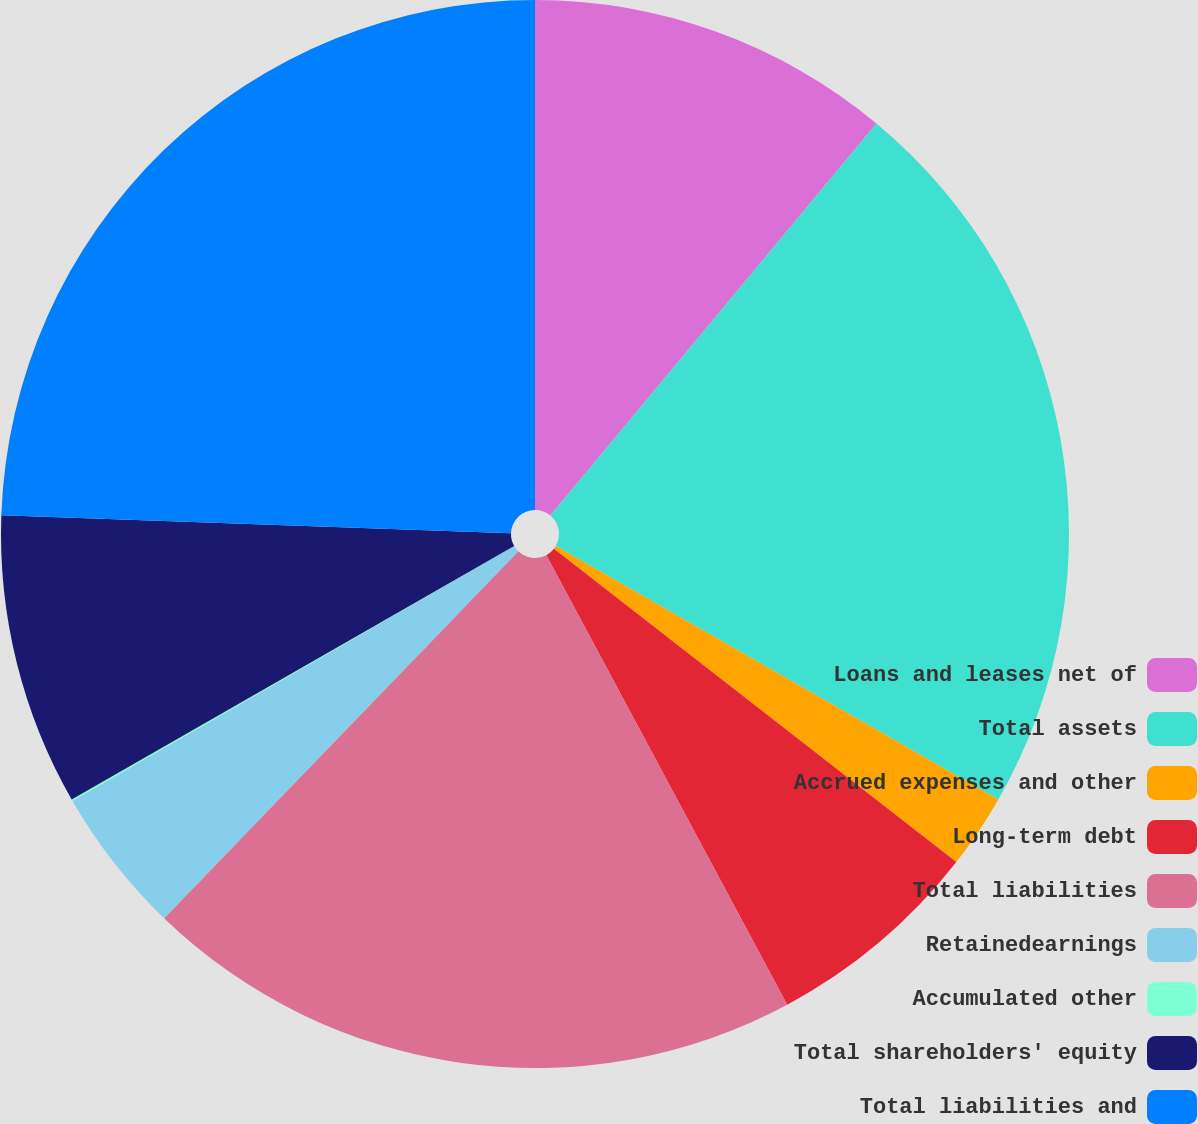Convert chart to OTSL. <chart><loc_0><loc_0><loc_500><loc_500><pie_chart><fcel>Loans and leases net of<fcel>Total assets<fcel>Accrued expenses and other<fcel>Long-term debt<fcel>Total liabilities<fcel>Retainedearnings<fcel>Accumulated other<fcel>Total shareholders' equity<fcel>Total liabilities and<nl><fcel>11.04%<fcel>22.24%<fcel>2.25%<fcel>6.64%<fcel>20.05%<fcel>4.45%<fcel>0.05%<fcel>8.84%<fcel>24.44%<nl></chart> 